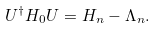<formula> <loc_0><loc_0><loc_500><loc_500>U ^ { \dagger } H _ { 0 } U = H _ { n } - \Lambda _ { n } .</formula> 